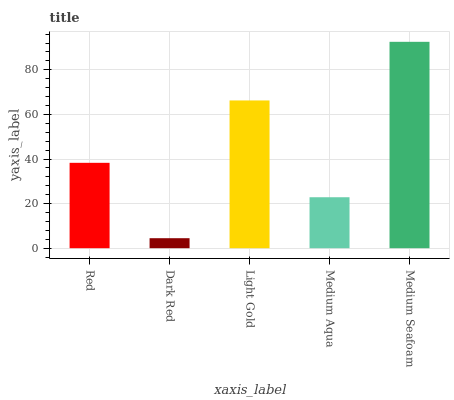Is Dark Red the minimum?
Answer yes or no. Yes. Is Medium Seafoam the maximum?
Answer yes or no. Yes. Is Light Gold the minimum?
Answer yes or no. No. Is Light Gold the maximum?
Answer yes or no. No. Is Light Gold greater than Dark Red?
Answer yes or no. Yes. Is Dark Red less than Light Gold?
Answer yes or no. Yes. Is Dark Red greater than Light Gold?
Answer yes or no. No. Is Light Gold less than Dark Red?
Answer yes or no. No. Is Red the high median?
Answer yes or no. Yes. Is Red the low median?
Answer yes or no. Yes. Is Medium Aqua the high median?
Answer yes or no. No. Is Dark Red the low median?
Answer yes or no. No. 